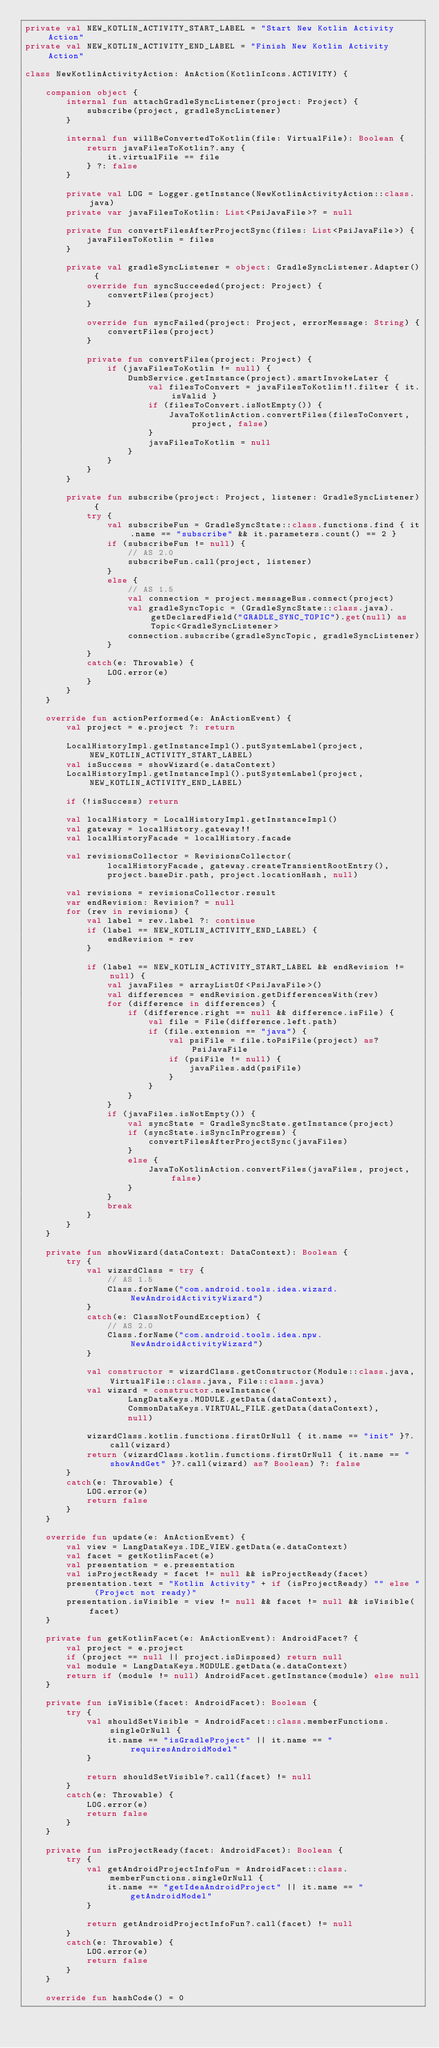<code> <loc_0><loc_0><loc_500><loc_500><_Kotlin_>private val NEW_KOTLIN_ACTIVITY_START_LABEL = "Start New Kotlin Activity Action"
private val NEW_KOTLIN_ACTIVITY_END_LABEL = "Finish New Kotlin Activity Action"

class NewKotlinActivityAction: AnAction(KotlinIcons.ACTIVITY) {

    companion object {
        internal fun attachGradleSyncListener(project: Project) {
            subscribe(project, gradleSyncListener)
        }

        internal fun willBeConvertedToKotlin(file: VirtualFile): Boolean {
            return javaFilesToKotlin?.any {
                it.virtualFile == file
            } ?: false
        }

        private val LOG = Logger.getInstance(NewKotlinActivityAction::class.java)
        private var javaFilesToKotlin: List<PsiJavaFile>? = null

        private fun convertFilesAfterProjectSync(files: List<PsiJavaFile>) {
            javaFilesToKotlin = files
        }

        private val gradleSyncListener = object: GradleSyncListener.Adapter() {
            override fun syncSucceeded(project: Project) {
                convertFiles(project)
            }

            override fun syncFailed(project: Project, errorMessage: String) {
                convertFiles(project)
            }

            private fun convertFiles(project: Project) {
                if (javaFilesToKotlin != null) {
                    DumbService.getInstance(project).smartInvokeLater {
                        val filesToConvert = javaFilesToKotlin!!.filter { it.isValid }
                        if (filesToConvert.isNotEmpty()) {
                            JavaToKotlinAction.convertFiles(filesToConvert, project, false)
                        }
                        javaFilesToKotlin = null
                    }
                }
            }
        }

        private fun subscribe(project: Project, listener: GradleSyncListener) {
            try {
                val subscribeFun = GradleSyncState::class.functions.find { it.name == "subscribe" && it.parameters.count() == 2 }
                if (subscribeFun != null) {
                    // AS 2.0
                    subscribeFun.call(project, listener)
                }
                else {
                    // AS 1.5
                    val connection = project.messageBus.connect(project)
                    val gradleSyncTopic = (GradleSyncState::class.java).getDeclaredField("GRADLE_SYNC_TOPIC").get(null) as Topic<GradleSyncListener>
                    connection.subscribe(gradleSyncTopic, gradleSyncListener)
                }
            }
            catch(e: Throwable) {
                LOG.error(e)
            }
        }
    }

    override fun actionPerformed(e: AnActionEvent) {
        val project = e.project ?: return

        LocalHistoryImpl.getInstanceImpl().putSystemLabel(project, NEW_KOTLIN_ACTIVITY_START_LABEL)
        val isSuccess = showWizard(e.dataContext)
        LocalHistoryImpl.getInstanceImpl().putSystemLabel(project, NEW_KOTLIN_ACTIVITY_END_LABEL)

        if (!isSuccess) return

        val localHistory = LocalHistoryImpl.getInstanceImpl()
        val gateway = localHistory.gateway!!
        val localHistoryFacade = localHistory.facade

        val revisionsCollector = RevisionsCollector(
                localHistoryFacade, gateway.createTransientRootEntry(),
                project.baseDir.path, project.locationHash, null)

        val revisions = revisionsCollector.result
        var endRevision: Revision? = null
        for (rev in revisions) {
            val label = rev.label ?: continue
            if (label == NEW_KOTLIN_ACTIVITY_END_LABEL) {
                endRevision = rev
            }

            if (label == NEW_KOTLIN_ACTIVITY_START_LABEL && endRevision != null) {
                val javaFiles = arrayListOf<PsiJavaFile>()
                val differences = endRevision.getDifferencesWith(rev)
                for (difference in differences) {
                    if (difference.right == null && difference.isFile) {
                        val file = File(difference.left.path)
                        if (file.extension == "java") {
                            val psiFile = file.toPsiFile(project) as? PsiJavaFile
                            if (psiFile != null) {
                                javaFiles.add(psiFile)
                            }
                        }
                    }
                }
                if (javaFiles.isNotEmpty()) {
                    val syncState = GradleSyncState.getInstance(project)
                    if (syncState.isSyncInProgress) {
                        convertFilesAfterProjectSync(javaFiles)
                    }
                    else {
                        JavaToKotlinAction.convertFiles(javaFiles, project, false)
                    }
                }
                break
            }
        }
    }

    private fun showWizard(dataContext: DataContext): Boolean {
        try {
            val wizardClass = try {
                // AS 1.5
                Class.forName("com.android.tools.idea.wizard.NewAndroidActivityWizard")
            }
            catch(e: ClassNotFoundException) {
                // AS 2.0
                Class.forName("com.android.tools.idea.npw.NewAndroidActivityWizard")
            }

            val constructor = wizardClass.getConstructor(Module::class.java, VirtualFile::class.java, File::class.java)
            val wizard = constructor.newInstance(
                    LangDataKeys.MODULE.getData(dataContext),
                    CommonDataKeys.VIRTUAL_FILE.getData(dataContext),
                    null)

            wizardClass.kotlin.functions.firstOrNull { it.name == "init" }?.call(wizard)
            return (wizardClass.kotlin.functions.firstOrNull { it.name == "showAndGet" }?.call(wizard) as? Boolean) ?: false
        }
        catch(e: Throwable) {
            LOG.error(e)
            return false
        }
    }

    override fun update(e: AnActionEvent) {
        val view = LangDataKeys.IDE_VIEW.getData(e.dataContext)
        val facet = getKotlinFacet(e)
        val presentation = e.presentation
        val isProjectReady = facet != null && isProjectReady(facet)
        presentation.text = "Kotlin Activity" + if (isProjectReady) "" else " (Project not ready)"
        presentation.isVisible = view != null && facet != null && isVisible(facet)
    }

    private fun getKotlinFacet(e: AnActionEvent): AndroidFacet? {
        val project = e.project
        if (project == null || project.isDisposed) return null
        val module = LangDataKeys.MODULE.getData(e.dataContext)
        return if (module != null) AndroidFacet.getInstance(module) else null
    }

    private fun isVisible(facet: AndroidFacet): Boolean {
        try {
            val shouldSetVisible = AndroidFacet::class.memberFunctions.singleOrNull {
                it.name == "isGradleProject" || it.name == "requiresAndroidModel"
            }

            return shouldSetVisible?.call(facet) != null
        }
        catch(e: Throwable) {
            LOG.error(e)
            return false
        }
    }

    private fun isProjectReady(facet: AndroidFacet): Boolean {
        try {
            val getAndroidProjectInfoFun = AndroidFacet::class.memberFunctions.singleOrNull {
                it.name == "getIdeaAndroidProject" || it.name == "getAndroidModel"
            }

            return getAndroidProjectInfoFun?.call(facet) != null
        }
        catch(e: Throwable) {
            LOG.error(e)
            return false
        }
    }

    override fun hashCode() = 0</code> 